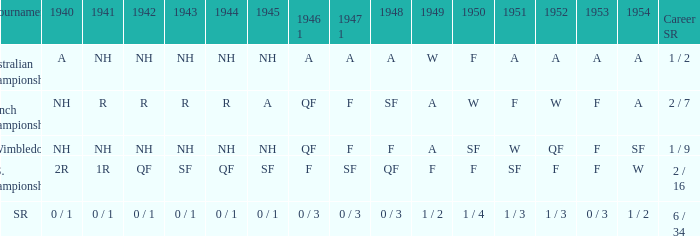What is the 1944 result for the U.S. Championships? QF. 